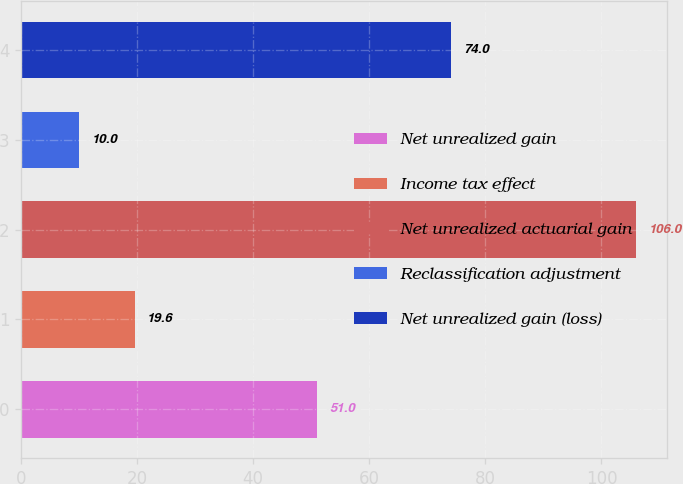<chart> <loc_0><loc_0><loc_500><loc_500><bar_chart><fcel>Net unrealized gain<fcel>Income tax effect<fcel>Net unrealized actuarial gain<fcel>Reclassification adjustment<fcel>Net unrealized gain (loss)<nl><fcel>51<fcel>19.6<fcel>106<fcel>10<fcel>74<nl></chart> 